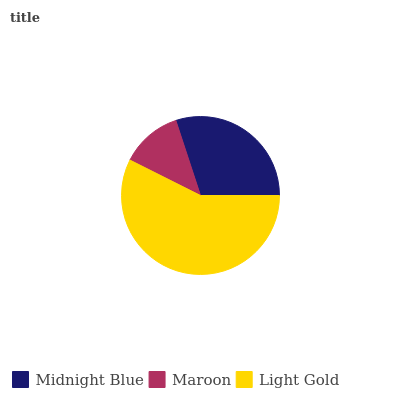Is Maroon the minimum?
Answer yes or no. Yes. Is Light Gold the maximum?
Answer yes or no. Yes. Is Light Gold the minimum?
Answer yes or no. No. Is Maroon the maximum?
Answer yes or no. No. Is Light Gold greater than Maroon?
Answer yes or no. Yes. Is Maroon less than Light Gold?
Answer yes or no. Yes. Is Maroon greater than Light Gold?
Answer yes or no. No. Is Light Gold less than Maroon?
Answer yes or no. No. Is Midnight Blue the high median?
Answer yes or no. Yes. Is Midnight Blue the low median?
Answer yes or no. Yes. Is Maroon the high median?
Answer yes or no. No. Is Light Gold the low median?
Answer yes or no. No. 